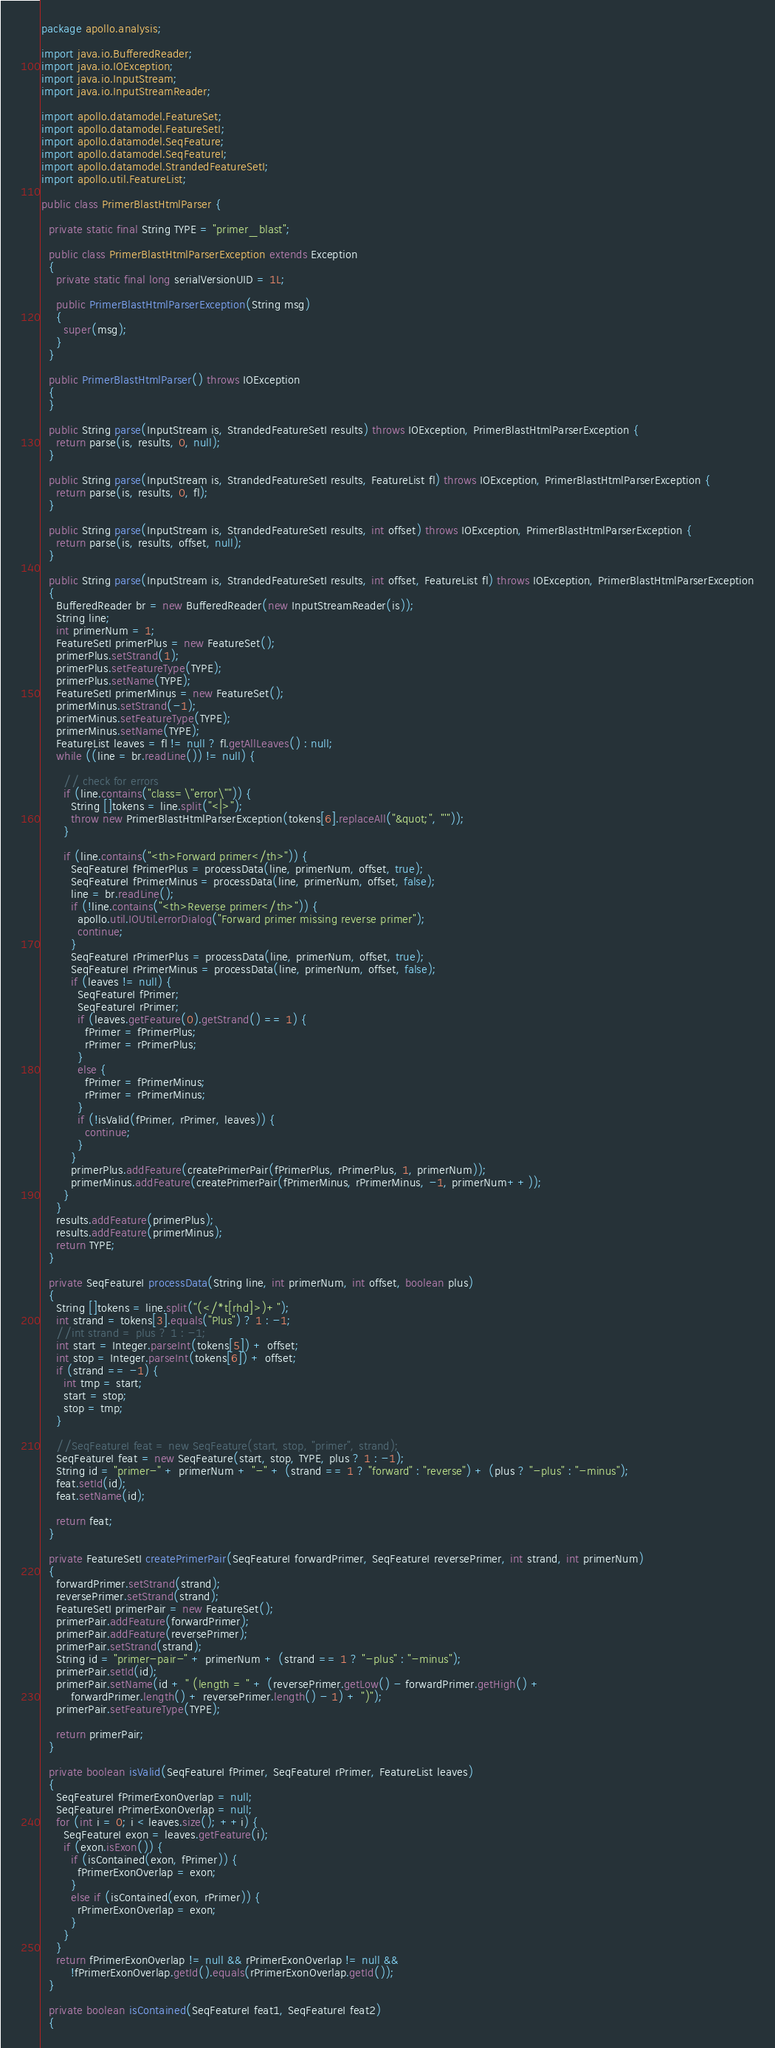Convert code to text. <code><loc_0><loc_0><loc_500><loc_500><_Java_>package apollo.analysis;

import java.io.BufferedReader;
import java.io.IOException;
import java.io.InputStream;
import java.io.InputStreamReader;

import apollo.datamodel.FeatureSet;
import apollo.datamodel.FeatureSetI;
import apollo.datamodel.SeqFeature;
import apollo.datamodel.SeqFeatureI;
import apollo.datamodel.StrandedFeatureSetI;
import apollo.util.FeatureList;

public class PrimerBlastHtmlParser {

  private static final String TYPE = "primer_blast";
  
  public class PrimerBlastHtmlParserException extends Exception
  {
    private static final long serialVersionUID = 1L;
    
    public PrimerBlastHtmlParserException(String msg)
    {
      super(msg);
    }
  }
  
  public PrimerBlastHtmlParser() throws IOException
  {
  }
  
  public String parse(InputStream is, StrandedFeatureSetI results) throws IOException, PrimerBlastHtmlParserException {
    return parse(is, results, 0, null);
  }
  
  public String parse(InputStream is, StrandedFeatureSetI results, FeatureList fl) throws IOException, PrimerBlastHtmlParserException {
    return parse(is, results, 0, fl);
  }
  
  public String parse(InputStream is, StrandedFeatureSetI results, int offset) throws IOException, PrimerBlastHtmlParserException {
    return parse(is, results, offset, null);
  }
  
  public String parse(InputStream is, StrandedFeatureSetI results, int offset, FeatureList fl) throws IOException, PrimerBlastHtmlParserException
  {
    BufferedReader br = new BufferedReader(new InputStreamReader(is));
    String line;
    int primerNum = 1;
    FeatureSetI primerPlus = new FeatureSet();
    primerPlus.setStrand(1);
    primerPlus.setFeatureType(TYPE);
    primerPlus.setName(TYPE);
    FeatureSetI primerMinus = new FeatureSet();
    primerMinus.setStrand(-1);
    primerMinus.setFeatureType(TYPE);
    primerMinus.setName(TYPE);
    FeatureList leaves = fl != null ? fl.getAllLeaves() : null;
    while ((line = br.readLine()) != null) {
      
      // check for errors
      if (line.contains("class=\"error\"")) {
        String []tokens = line.split("<|>");
        throw new PrimerBlastHtmlParserException(tokens[6].replaceAll("&quot;", "'"));
      }
      
      if (line.contains("<th>Forward primer</th>")) {
        SeqFeatureI fPrimerPlus = processData(line, primerNum, offset, true);
        SeqFeatureI fPrimerMinus = processData(line, primerNum, offset, false);
        line = br.readLine();
        if (!line.contains("<th>Reverse primer</th>")) {
          apollo.util.IOUtil.errorDialog("Forward primer missing reverse primer");
          continue;
        }
        SeqFeatureI rPrimerPlus = processData(line, primerNum, offset, true);
        SeqFeatureI rPrimerMinus = processData(line, primerNum, offset, false);
        if (leaves != null) {
          SeqFeatureI fPrimer;
          SeqFeatureI rPrimer;
          if (leaves.getFeature(0).getStrand() == 1) {
            fPrimer = fPrimerPlus;
            rPrimer = rPrimerPlus;
          }
          else {
            fPrimer = fPrimerMinus;
            rPrimer = rPrimerMinus;
          }
          if (!isValid(fPrimer, rPrimer, leaves)) {
            continue;
          }
        }
        primerPlus.addFeature(createPrimerPair(fPrimerPlus, rPrimerPlus, 1, primerNum));
        primerMinus.addFeature(createPrimerPair(fPrimerMinus, rPrimerMinus, -1, primerNum++));
      }
    }
    results.addFeature(primerPlus);
    results.addFeature(primerMinus);
    return TYPE;
  }

  private SeqFeatureI processData(String line, int primerNum, int offset, boolean plus)
  {
    String []tokens = line.split("(</*t[rhd]>)+");
    int strand = tokens[3].equals("Plus") ? 1 : -1;
    //int strand = plus ? 1 : -1;
    int start = Integer.parseInt(tokens[5]) + offset;
    int stop = Integer.parseInt(tokens[6]) + offset;
    if (strand == -1) {
      int tmp = start;
      start = stop;
      stop = tmp;
    }

    //SeqFeatureI feat = new SeqFeature(start, stop, "primer", strand);
    SeqFeatureI feat = new SeqFeature(start, stop, TYPE, plus ? 1 : -1);
    String id = "primer-" + primerNum + "-" + (strand == 1 ? "forward" : "reverse") + (plus ? "-plus" : "-minus");
    feat.setId(id);
    feat.setName(id);
    
    return feat;
  }
  
  private FeatureSetI createPrimerPair(SeqFeatureI forwardPrimer, SeqFeatureI reversePrimer, int strand, int primerNum)
  {
    forwardPrimer.setStrand(strand);
    reversePrimer.setStrand(strand);
    FeatureSetI primerPair = new FeatureSet();
    primerPair.addFeature(forwardPrimer);
    primerPair.addFeature(reversePrimer);
    primerPair.setStrand(strand);
    String id = "primer-pair-" + primerNum + (strand == 1 ? "-plus" : "-minus");
    primerPair.setId(id);
    primerPair.setName(id + " (length = " + (reversePrimer.getLow() - forwardPrimer.getHigh() +
        forwardPrimer.length() + reversePrimer.length() - 1) + ")");
    primerPair.setFeatureType(TYPE);

    return primerPair;
  }
  
  private boolean isValid(SeqFeatureI fPrimer, SeqFeatureI rPrimer, FeatureList leaves)
  {
    SeqFeatureI fPrimerExonOverlap = null;
    SeqFeatureI rPrimerExonOverlap = null;
    for (int i = 0; i < leaves.size(); ++i) {
      SeqFeatureI exon = leaves.getFeature(i);
      if (exon.isExon()) {
        if (isContained(exon, fPrimer)) {
          fPrimerExonOverlap = exon;
        }
        else if (isContained(exon, rPrimer)) {
          rPrimerExonOverlap = exon;
        }
      }
    }
    return fPrimerExonOverlap != null && rPrimerExonOverlap != null &&
        !fPrimerExonOverlap.getId().equals(rPrimerExonOverlap.getId());
  }
  
  private boolean isContained(SeqFeatureI feat1, SeqFeatureI feat2)
  {</code> 